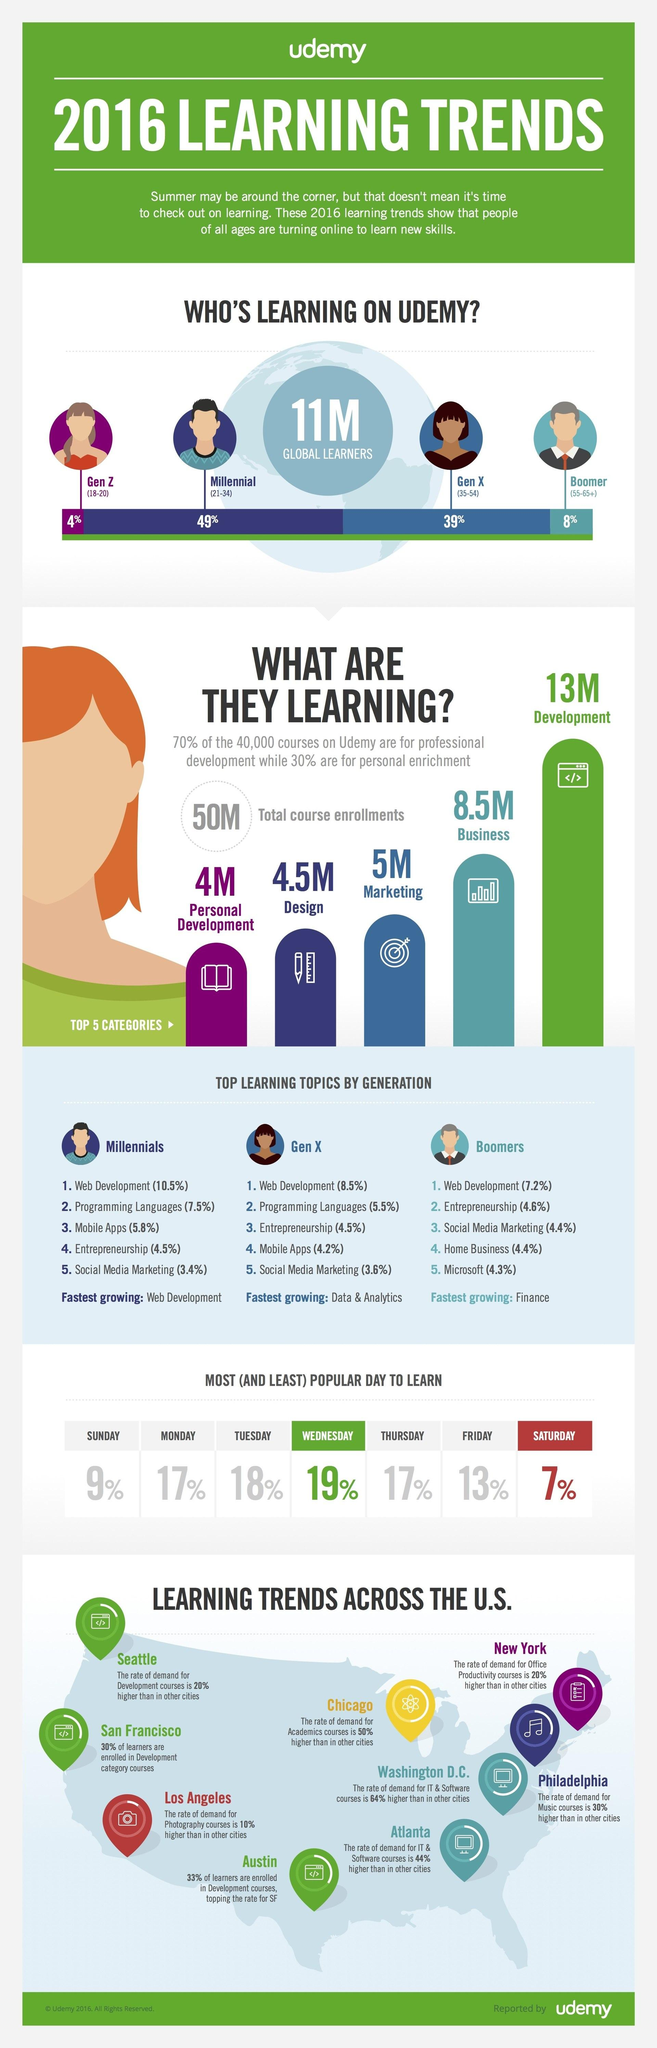Specify some key components in this picture. According to the information provided, a significant portion of people belonging to the Gen X demographic use Udemy for learning, with 39% of this group reporting that they utilize the platform for education. A recent survey found that 17% of people prefer to learn on Mondays and Thursdays. Social Media Marketing is the fifth most preferred topic among Millenials and Gen X, and the third most preferred among Boomers. Programming languages are the second most popular course among Millennials and Gen X. According to recent data, cities such as Seattle, San Francisco, and Austin in the United States have the highest demand for enrolling in development courses. 